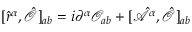Convert formula to latex. <formula><loc_0><loc_0><loc_500><loc_500>[ \hat { r } ^ { \alpha } , \hat { \mathcal { O } } ] _ { a b } = i \partial ^ { \alpha } \mathcal { O } _ { a b } + [ \hat { \mathcal { A } } ^ { \alpha } , \hat { \mathcal { O } } ] _ { a b }</formula> 